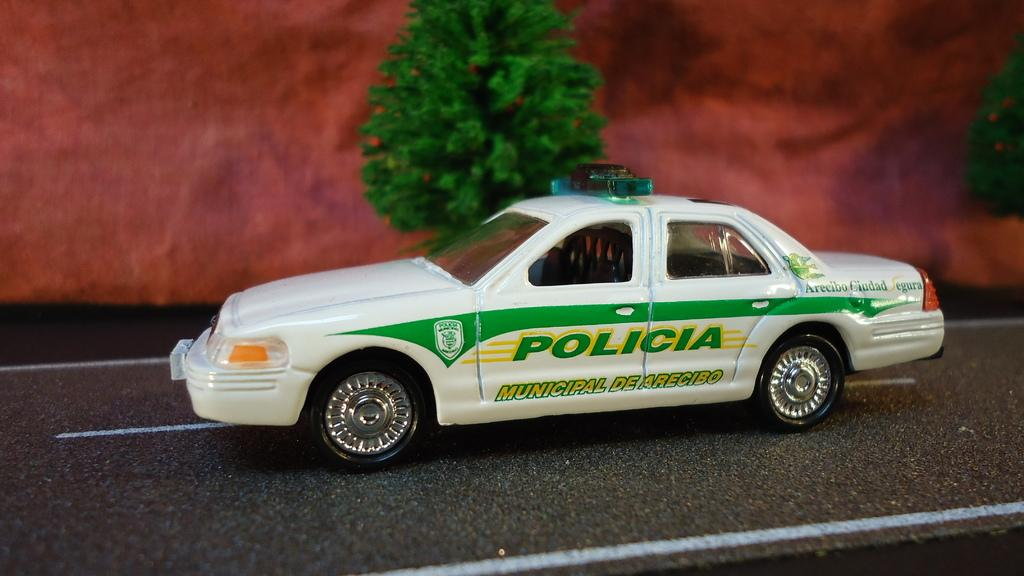What is on the road in the image? There is a car on the road in the image. What type of natural scenery can be seen in the image? Trees are visible in the image. What color is predominant in the background of the image? The background has a maroon color. What type of drum can be seen in the image? There is no drum present in the image. What kind of soup is being served in the image? There is no soup present in the image. 